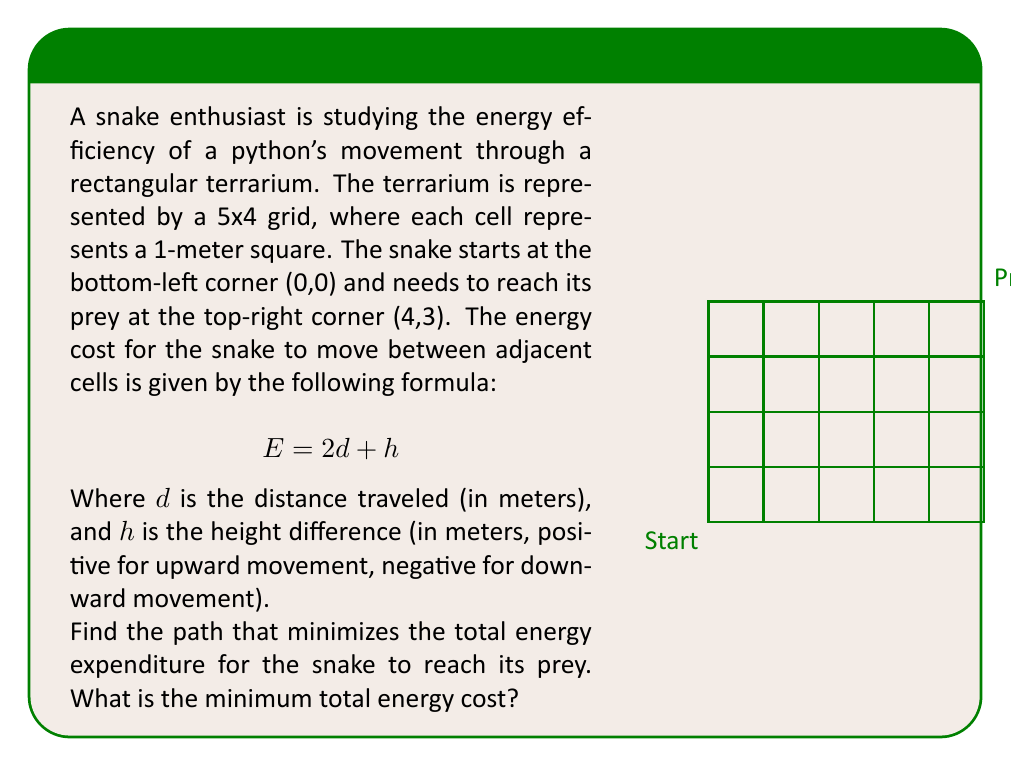Help me with this question. To solve this problem, we can use dynamic programming. Let's break it down step-by-step:

1) First, we create a 5x4 grid to represent the terrarium. Each cell (i,j) will store the minimum energy cost to reach that cell from the start.

2) Initialize the grid:
   - Set (0,0) to 0 (starting point)
   - Set all other cells to infinity (we haven't calculated their costs yet)

3) For each cell (i,j), we calculate the minimum energy cost to reach it from its left and bottom neighbors:
   - From left: $E_{left} = grid[i-1][j] + 2$ (2 meters horizontal movement)
   - From bottom: $E_{bottom} = grid[i][j-1] + 2 + 1$ (2 meters horizontal + 1 meter upward)

4) We fill the grid from left to right, bottom to top, using the formula:
   $grid[i][j] = min(E_{left}, E_{bottom})$

5) After filling the entire grid, the value in cell (4,3) will be the minimum total energy cost.

Here's how the grid looks after filling (rounded to integers for clarity):

$$
\begin{bmatrix}
9 & 7 & 5 & 3 & 5 \\
7 & 5 & 3 & 5 & 7 \\
5 & 3 & 5 & 7 & 9 \\
3 & 5 & 7 & 9 & 11
\end{bmatrix}
$$

6) The minimum total energy cost is 11, found in cell (4,3).

7) To find the actual path, we can backtrack from (4,3) to (0,0), always choosing the cell that led to the current minimum cost. This gives us the path: (0,0) -> (1,0) -> (2,0) -> (3,0) -> (4,0) -> (4,1) -> (4,2) -> (4,3).
Answer: 11 energy units 